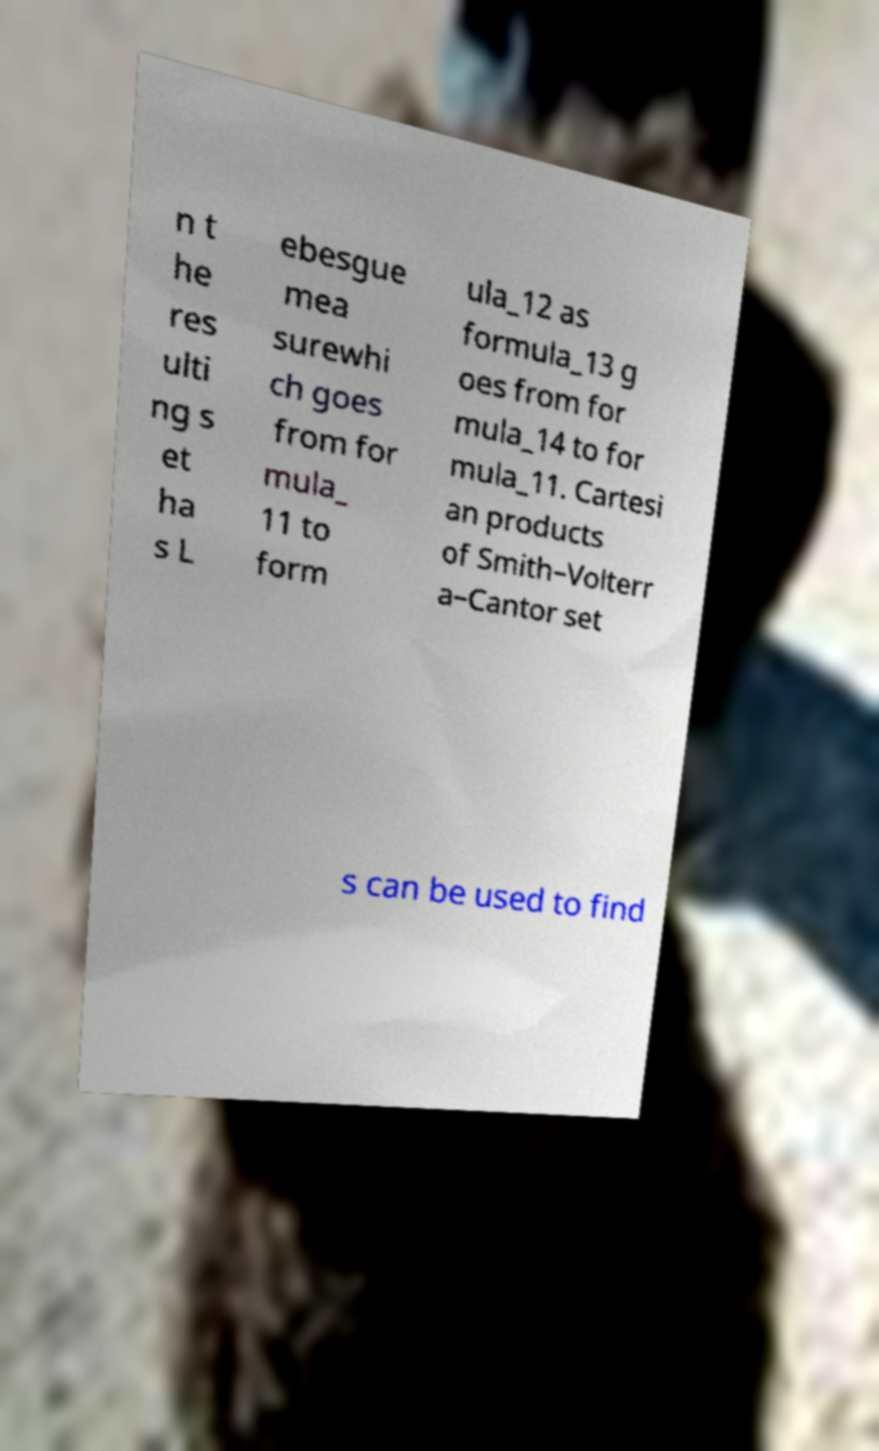Please identify and transcribe the text found in this image. n t he res ulti ng s et ha s L ebesgue mea surewhi ch goes from for mula_ 11 to form ula_12 as formula_13 g oes from for mula_14 to for mula_11. Cartesi an products of Smith–Volterr a–Cantor set s can be used to find 